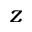Convert formula to latex. <formula><loc_0><loc_0><loc_500><loc_500>z</formula> 